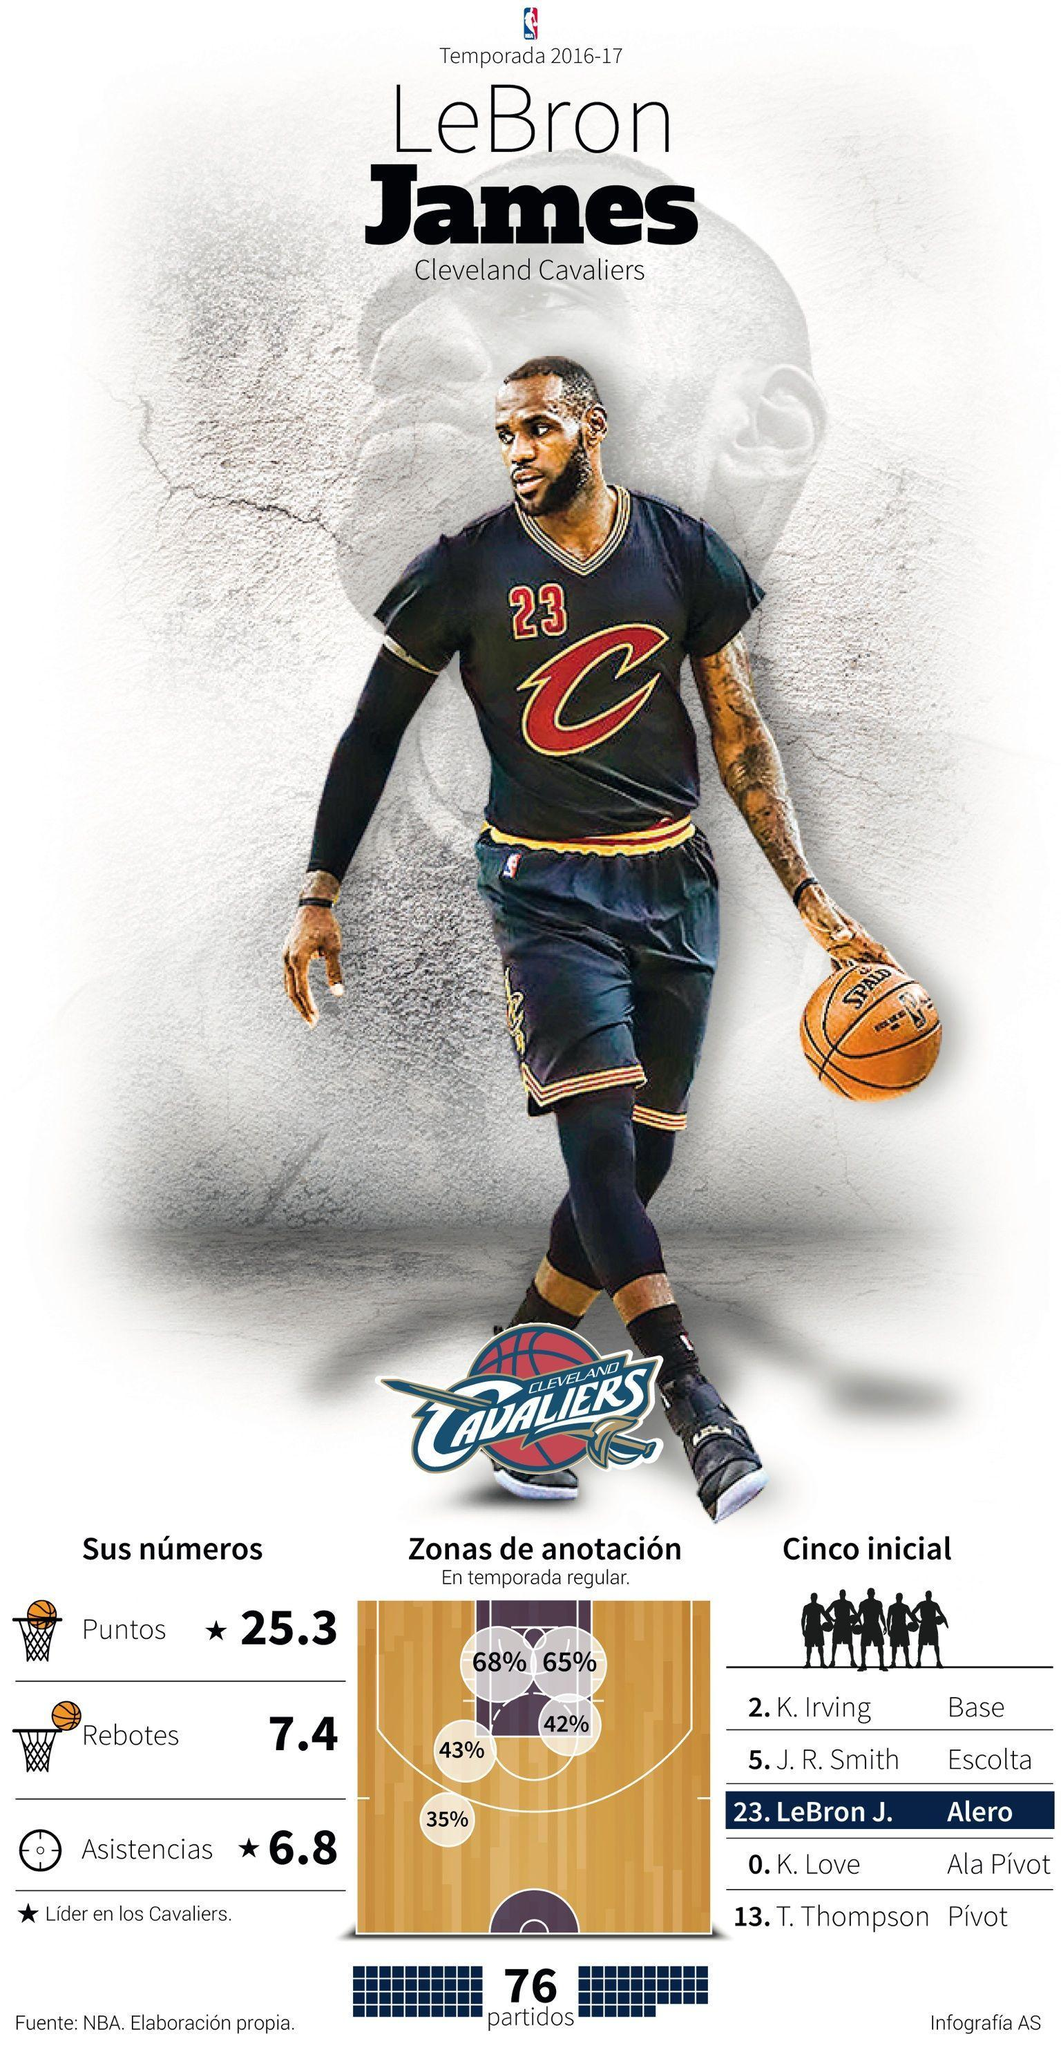What is the number written on the t shirt
Answer the question with a short phrase. 23 